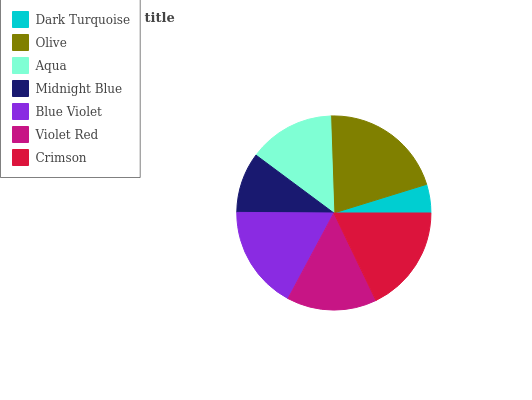Is Dark Turquoise the minimum?
Answer yes or no. Yes. Is Olive the maximum?
Answer yes or no. Yes. Is Aqua the minimum?
Answer yes or no. No. Is Aqua the maximum?
Answer yes or no. No. Is Olive greater than Aqua?
Answer yes or no. Yes. Is Aqua less than Olive?
Answer yes or no. Yes. Is Aqua greater than Olive?
Answer yes or no. No. Is Olive less than Aqua?
Answer yes or no. No. Is Violet Red the high median?
Answer yes or no. Yes. Is Violet Red the low median?
Answer yes or no. Yes. Is Dark Turquoise the high median?
Answer yes or no. No. Is Aqua the low median?
Answer yes or no. No. 